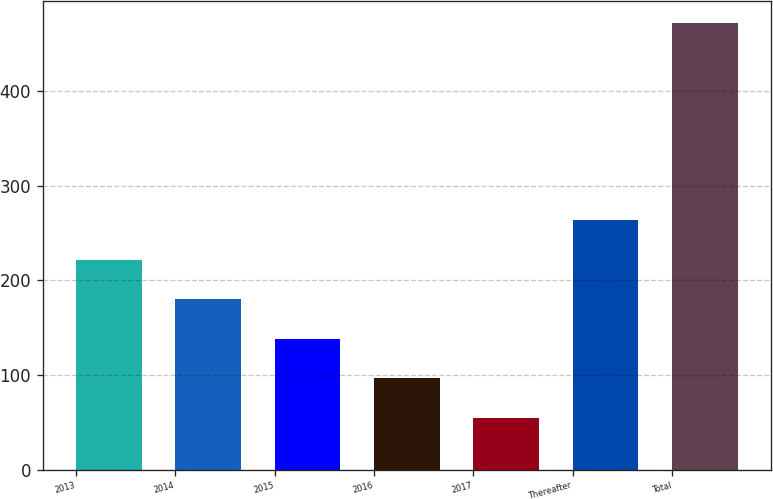<chart> <loc_0><loc_0><loc_500><loc_500><bar_chart><fcel>2013<fcel>2014<fcel>2015<fcel>2016<fcel>2017<fcel>Thereafter<fcel>Total<nl><fcel>221.8<fcel>180.1<fcel>138.4<fcel>96.7<fcel>55<fcel>263.5<fcel>472<nl></chart> 